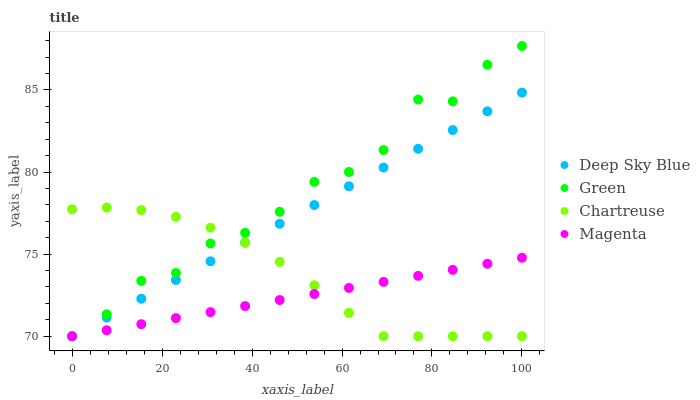Does Magenta have the minimum area under the curve?
Answer yes or no. Yes. Does Green have the maximum area under the curve?
Answer yes or no. Yes. Does Green have the minimum area under the curve?
Answer yes or no. No. Does Magenta have the maximum area under the curve?
Answer yes or no. No. Is Deep Sky Blue the smoothest?
Answer yes or no. Yes. Is Green the roughest?
Answer yes or no. Yes. Is Magenta the smoothest?
Answer yes or no. No. Is Magenta the roughest?
Answer yes or no. No. Does Chartreuse have the lowest value?
Answer yes or no. Yes. Does Green have the highest value?
Answer yes or no. Yes. Does Magenta have the highest value?
Answer yes or no. No. Does Deep Sky Blue intersect Magenta?
Answer yes or no. Yes. Is Deep Sky Blue less than Magenta?
Answer yes or no. No. Is Deep Sky Blue greater than Magenta?
Answer yes or no. No. 